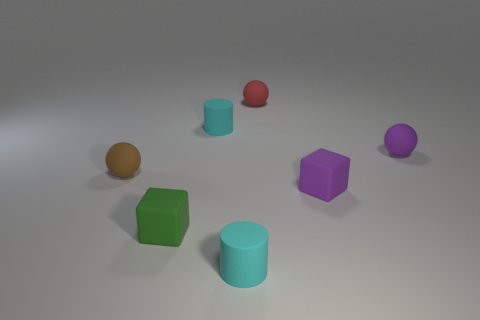What is the color of the other cube that is the same size as the purple block?
Make the answer very short. Green. What is the shape of the thing that is behind the small purple sphere and in front of the red thing?
Your response must be concise. Cylinder. There is a cyan cylinder that is in front of the matte ball on the left side of the red matte ball; what is its size?
Provide a short and direct response. Small. What number of other objects are there of the same size as the brown object?
Keep it short and to the point. 6. What size is the matte ball that is both right of the small green cube and on the left side of the small purple cube?
Make the answer very short. Small. What number of tiny purple things have the same shape as the tiny green thing?
Offer a terse response. 1. What is the material of the purple ball?
Ensure brevity in your answer.  Rubber. Does the green rubber thing have the same shape as the red rubber object?
Your answer should be very brief. No. Are there any small purple balls made of the same material as the purple block?
Give a very brief answer. Yes. What color is the small matte thing that is behind the purple matte ball and left of the red rubber thing?
Provide a succinct answer. Cyan. 